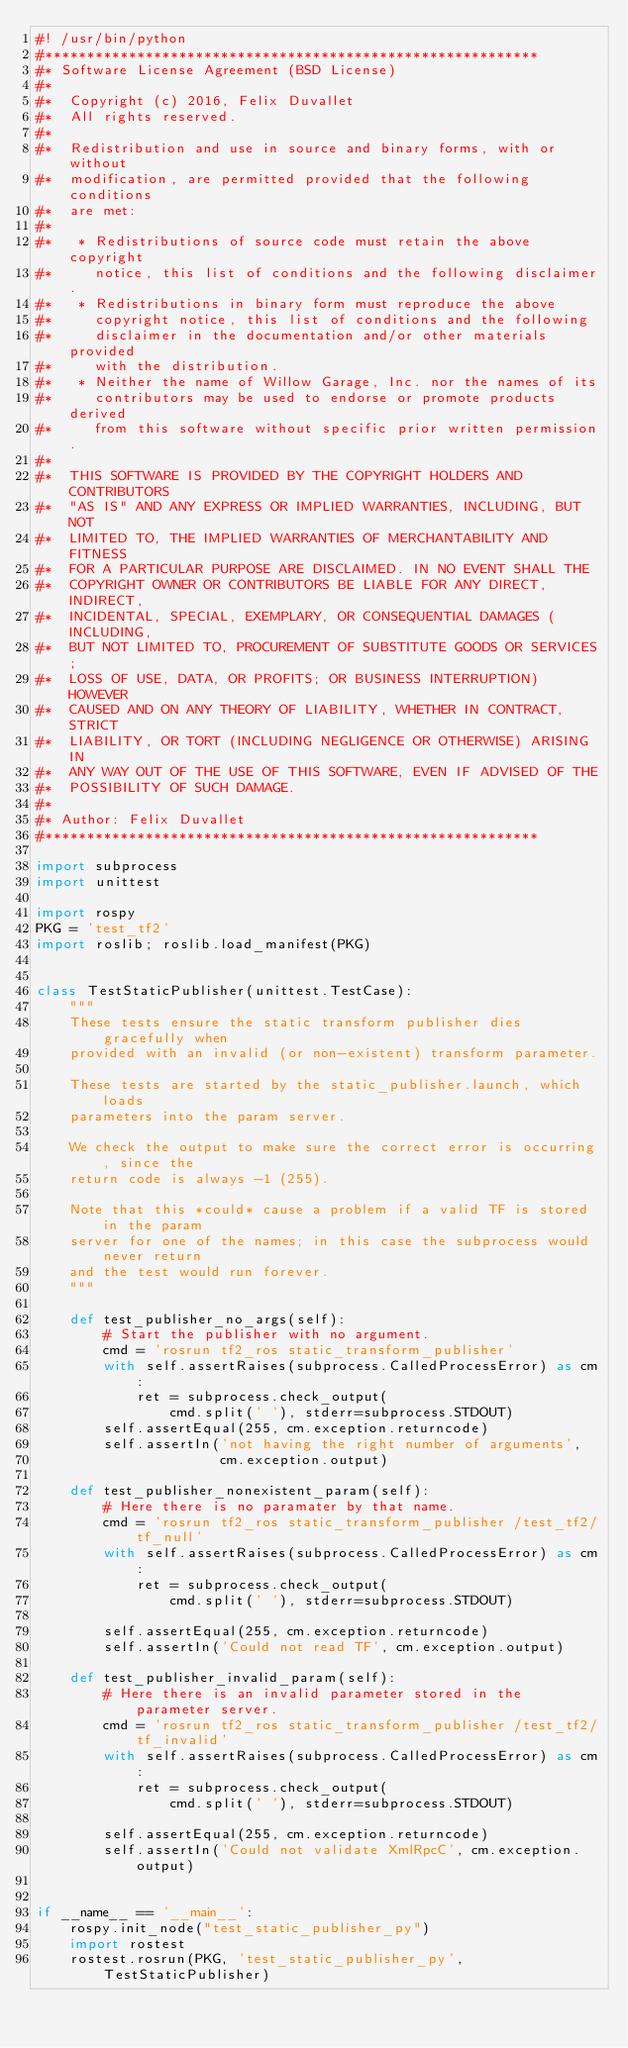<code> <loc_0><loc_0><loc_500><loc_500><_Python_>#! /usr/bin/python
#***********************************************************
#* Software License Agreement (BSD License)
#*
#*  Copyright (c) 2016, Felix Duvallet
#*  All rights reserved.
#*
#*  Redistribution and use in source and binary forms, with or without
#*  modification, are permitted provided that the following conditions
#*  are met:
#*
#*   * Redistributions of source code must retain the above copyright
#*     notice, this list of conditions and the following disclaimer.
#*   * Redistributions in binary form must reproduce the above
#*     copyright notice, this list of conditions and the following
#*     disclaimer in the documentation and/or other materials provided
#*     with the distribution.
#*   * Neither the name of Willow Garage, Inc. nor the names of its
#*     contributors may be used to endorse or promote products derived
#*     from this software without specific prior written permission.
#*
#*  THIS SOFTWARE IS PROVIDED BY THE COPYRIGHT HOLDERS AND CONTRIBUTORS
#*  "AS IS" AND ANY EXPRESS OR IMPLIED WARRANTIES, INCLUDING, BUT NOT
#*  LIMITED TO, THE IMPLIED WARRANTIES OF MERCHANTABILITY AND FITNESS
#*  FOR A PARTICULAR PURPOSE ARE DISCLAIMED. IN NO EVENT SHALL THE
#*  COPYRIGHT OWNER OR CONTRIBUTORS BE LIABLE FOR ANY DIRECT, INDIRECT,
#*  INCIDENTAL, SPECIAL, EXEMPLARY, OR CONSEQUENTIAL DAMAGES (INCLUDING,
#*  BUT NOT LIMITED TO, PROCUREMENT OF SUBSTITUTE GOODS OR SERVICES;
#*  LOSS OF USE, DATA, OR PROFITS; OR BUSINESS INTERRUPTION) HOWEVER
#*  CAUSED AND ON ANY THEORY OF LIABILITY, WHETHER IN CONTRACT, STRICT
#*  LIABILITY, OR TORT (INCLUDING NEGLIGENCE OR OTHERWISE) ARISING IN
#*  ANY WAY OUT OF THE USE OF THIS SOFTWARE, EVEN IF ADVISED OF THE
#*  POSSIBILITY OF SUCH DAMAGE.
#* 
#* Author: Felix Duvallet
#***********************************************************

import subprocess
import unittest

import rospy
PKG = 'test_tf2'
import roslib; roslib.load_manifest(PKG)


class TestStaticPublisher(unittest.TestCase):
    """
    These tests ensure the static transform publisher dies gracefully when
    provided with an invalid (or non-existent) transform parameter.

    These tests are started by the static_publisher.launch, which loads
    parameters into the param server.

    We check the output to make sure the correct error is occurring, since the
    return code is always -1 (255).

    Note that this *could* cause a problem if a valid TF is stored in the param
    server for one of the names; in this case the subprocess would never return
    and the test would run forever.
    """

    def test_publisher_no_args(self):
        # Start the publisher with no argument.
        cmd = 'rosrun tf2_ros static_transform_publisher'
        with self.assertRaises(subprocess.CalledProcessError) as cm:
            ret = subprocess.check_output(
                cmd.split(' '), stderr=subprocess.STDOUT)
        self.assertEqual(255, cm.exception.returncode)
        self.assertIn('not having the right number of arguments',
                      cm.exception.output)

    def test_publisher_nonexistent_param(self):
        # Here there is no paramater by that name.
        cmd = 'rosrun tf2_ros static_transform_publisher /test_tf2/tf_null'
        with self.assertRaises(subprocess.CalledProcessError) as cm:
            ret = subprocess.check_output(
                cmd.split(' '), stderr=subprocess.STDOUT)

        self.assertEqual(255, cm.exception.returncode)
        self.assertIn('Could not read TF', cm.exception.output)

    def test_publisher_invalid_param(self):
        # Here there is an invalid parameter stored in the parameter server.
        cmd = 'rosrun tf2_ros static_transform_publisher /test_tf2/tf_invalid'
        with self.assertRaises(subprocess.CalledProcessError) as cm:
            ret = subprocess.check_output(
                cmd.split(' '), stderr=subprocess.STDOUT)

        self.assertEqual(255, cm.exception.returncode)
        self.assertIn('Could not validate XmlRpcC', cm.exception.output)


if __name__ == '__main__':
    rospy.init_node("test_static_publisher_py")
    import rostest
    rostest.rosrun(PKG, 'test_static_publisher_py', TestStaticPublisher)
</code> 